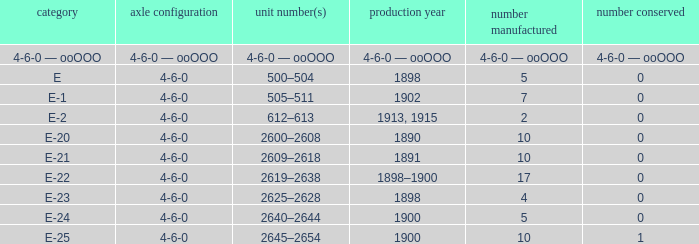What is the wheel arrangement with 1 quantity preserved? 4-6-0. 